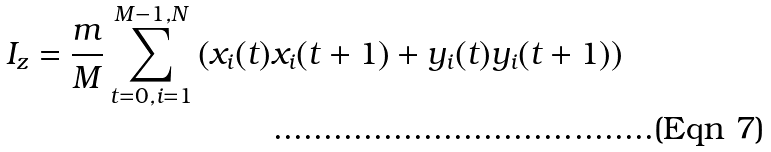<formula> <loc_0><loc_0><loc_500><loc_500>I _ { z } = \frac { m } { M } \sum _ { t = 0 , i = 1 } ^ { M - 1 , N } \left ( x _ { i } ( t ) x _ { i } ( t + 1 ) + y _ { i } ( t ) y _ { i } ( t + 1 ) \right )</formula> 